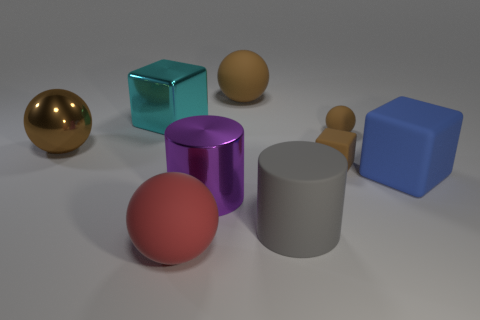Is the large cyan thing made of the same material as the large ball that is on the right side of the big red rubber ball?
Your response must be concise. No. Are there more blocks that are in front of the large blue rubber object than large blue rubber blocks that are left of the big cyan cube?
Offer a very short reply. No. The brown metallic thing is what shape?
Make the answer very short. Sphere. Does the big brown sphere that is behind the brown shiny sphere have the same material as the brown thing left of the big cyan cube?
Keep it short and to the point. No. There is a metal object in front of the blue block; what shape is it?
Your answer should be very brief. Cylinder. The other object that is the same shape as the gray thing is what size?
Offer a terse response. Large. Is the matte cylinder the same color as the small matte cube?
Your answer should be compact. No. Are there any other things that are the same shape as the blue object?
Ensure brevity in your answer.  Yes. Are there any large purple cylinders that are on the right side of the large shiny object right of the large cyan metal block?
Offer a terse response. No. The small object that is the same shape as the large brown shiny object is what color?
Make the answer very short. Brown. 